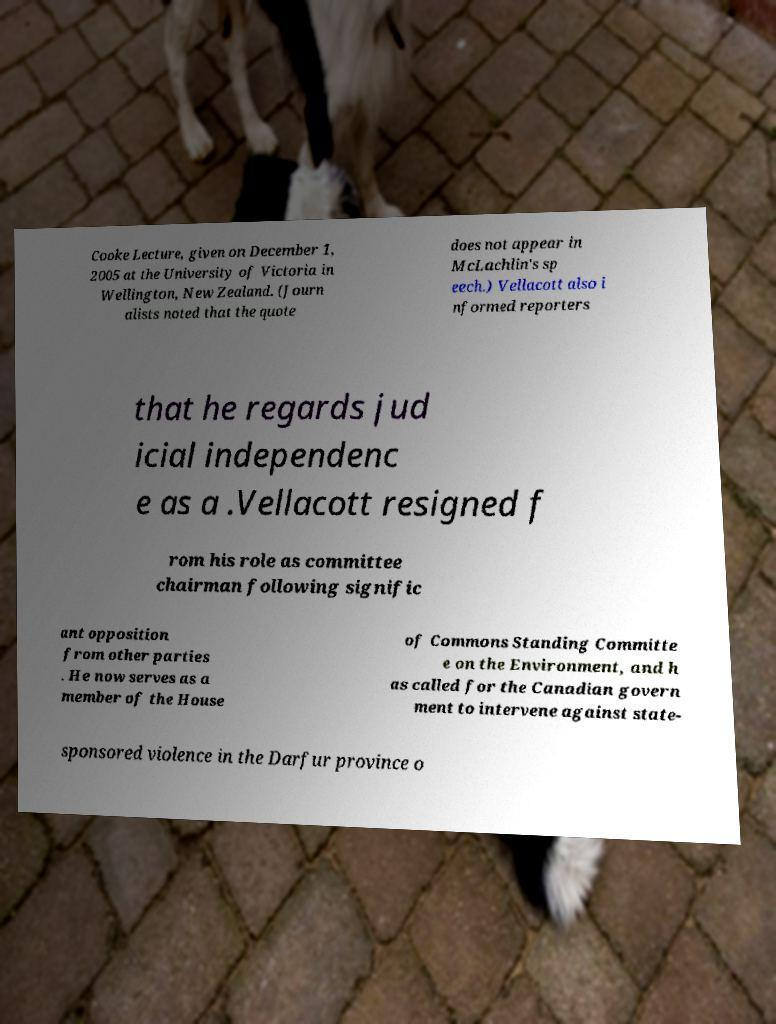I need the written content from this picture converted into text. Can you do that? Cooke Lecture, given on December 1, 2005 at the University of Victoria in Wellington, New Zealand. (Journ alists noted that the quote does not appear in McLachlin's sp eech.) Vellacott also i nformed reporters that he regards jud icial independenc e as a .Vellacott resigned f rom his role as committee chairman following signific ant opposition from other parties . He now serves as a member of the House of Commons Standing Committe e on the Environment, and h as called for the Canadian govern ment to intervene against state- sponsored violence in the Darfur province o 